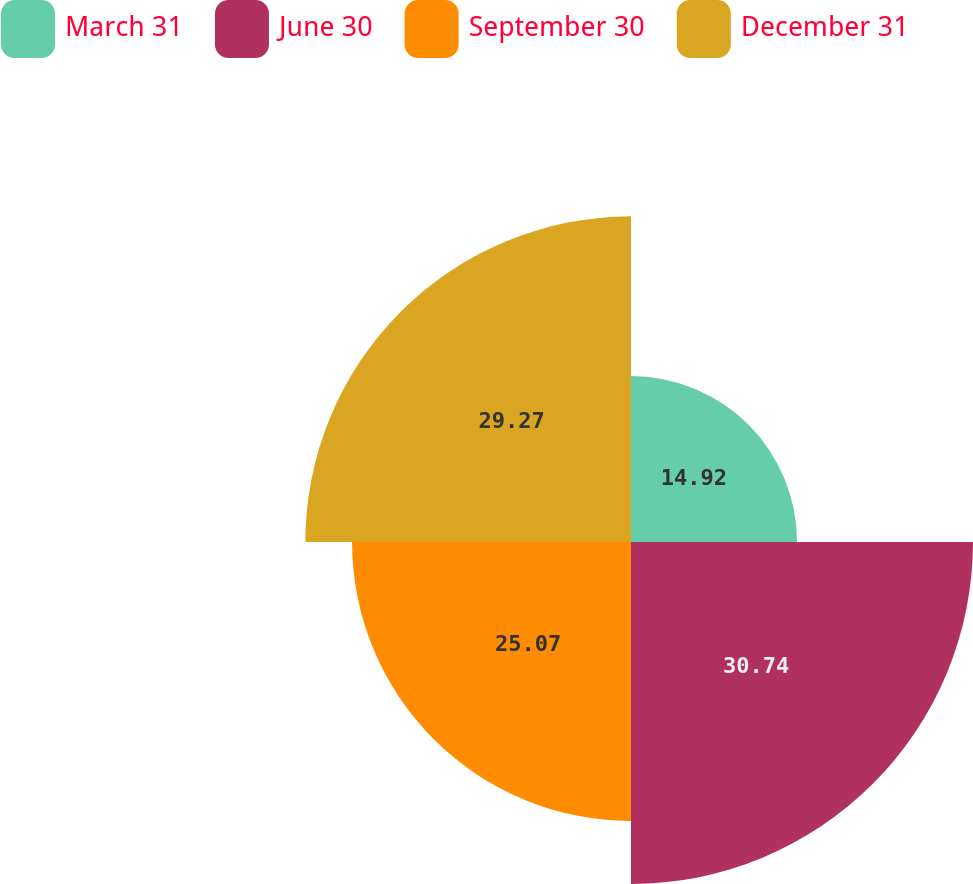Convert chart. <chart><loc_0><loc_0><loc_500><loc_500><pie_chart><fcel>March 31<fcel>June 30<fcel>September 30<fcel>December 31<nl><fcel>14.92%<fcel>30.74%<fcel>25.07%<fcel>29.27%<nl></chart> 